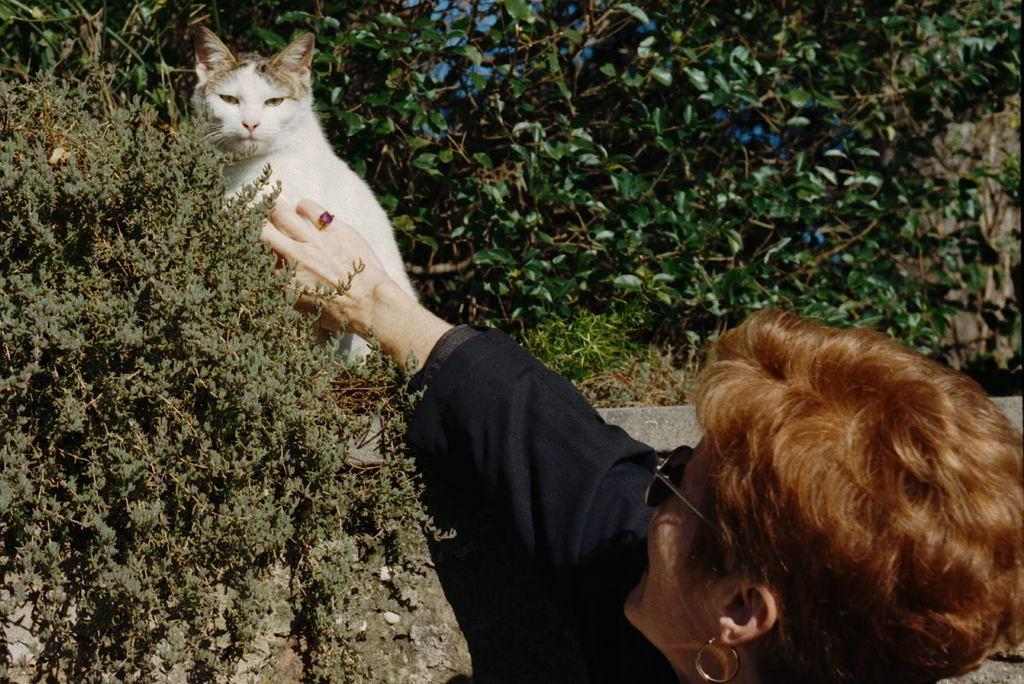What type of animal is in the image? There is a white cat in the image. Where is the cat located? The cat is sitting on a wall. What is the woman in the image wearing? The woman is wearing a black dress, goggles, and earrings. What is the woman doing in the image? The woman is touching the cat. What else can be seen in the image besides the cat and the woman? There is a small plant and trees visible in the background of the image. What type of motion is the finger performing in the image? There is no finger motion present in the image. The woman is touching the cat with her hand, but no specific finger motion is mentioned or depicted. 